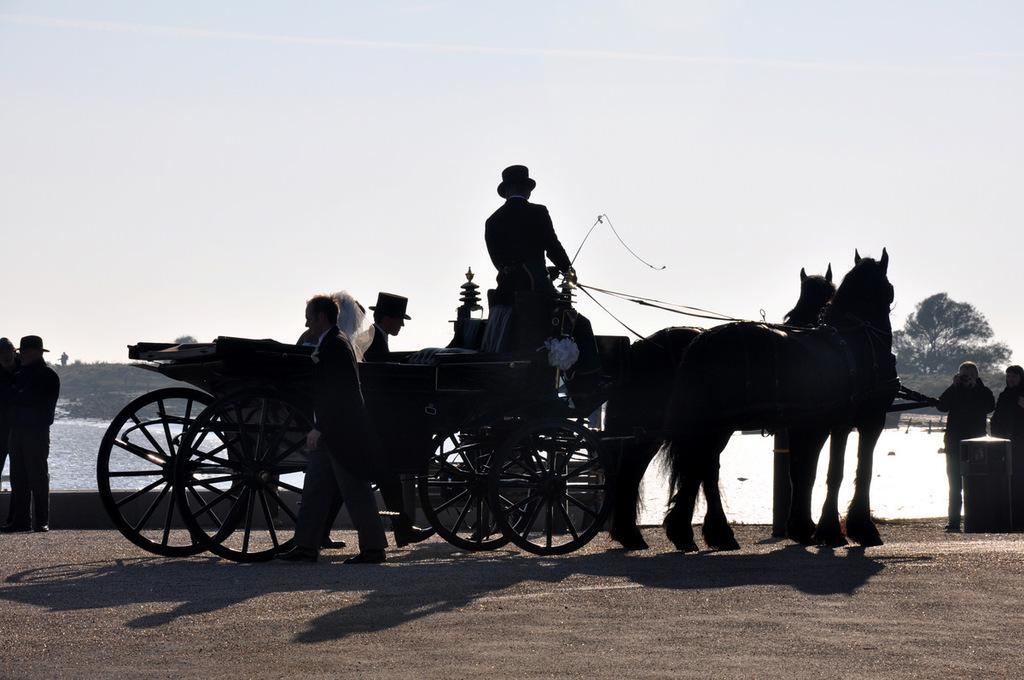What type of vehicle is in the image? There is a horse cart in the image. What are the people near the cart doing? There are people walking near the cart. Who is on the cart? There is a person sitting on the cart. What can be seen in the background of the image? There is water visible in the image. What is the condition of the sky in the image? The sky is clear in the image. How many chairs can be seen in the image? There are no chairs present in the image. What type of hook is used to attach the horse to the cart? There is no hook visible in the image; the horse is attached to the cart through other means. 